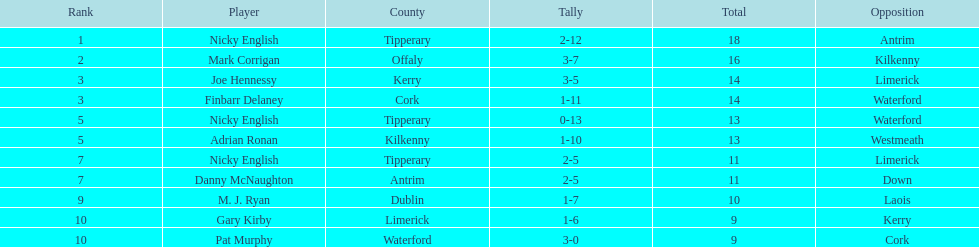Can you give me this table as a dict? {'header': ['Rank', 'Player', 'County', 'Tally', 'Total', 'Opposition'], 'rows': [['1', 'Nicky English', 'Tipperary', '2-12', '18', 'Antrim'], ['2', 'Mark Corrigan', 'Offaly', '3-7', '16', 'Kilkenny'], ['3', 'Joe Hennessy', 'Kerry', '3-5', '14', 'Limerick'], ['3', 'Finbarr Delaney', 'Cork', '1-11', '14', 'Waterford'], ['5', 'Nicky English', 'Tipperary', '0-13', '13', 'Waterford'], ['5', 'Adrian Ronan', 'Kilkenny', '1-10', '13', 'Westmeath'], ['7', 'Nicky English', 'Tipperary', '2-5', '11', 'Limerick'], ['7', 'Danny McNaughton', 'Antrim', '2-5', '11', 'Down'], ['9', 'M. J. Ryan', 'Dublin', '1-7', '10', 'Laois'], ['10', 'Gary Kirby', 'Limerick', '1-6', '9', 'Kerry'], ['10', 'Pat Murphy', 'Waterford', '3-0', '9', 'Cork']]} What is the foremost name on the list? Nicky English. 